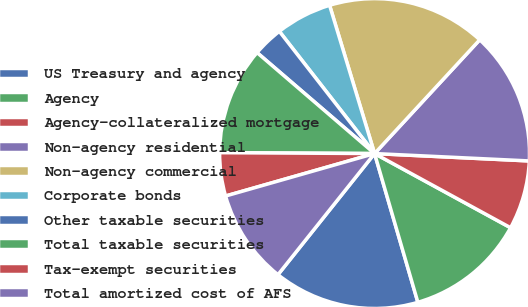Convert chart. <chart><loc_0><loc_0><loc_500><loc_500><pie_chart><fcel>US Treasury and agency<fcel>Agency<fcel>Agency-collateralized mortgage<fcel>Non-agency residential<fcel>Non-agency commercial<fcel>Corporate bonds<fcel>Other taxable securities<fcel>Total taxable securities<fcel>Tax-exempt securities<fcel>Total amortized cost of AFS<nl><fcel>15.23%<fcel>12.55%<fcel>7.19%<fcel>13.89%<fcel>16.57%<fcel>5.85%<fcel>3.17%<fcel>11.21%<fcel>4.51%<fcel>9.87%<nl></chart> 